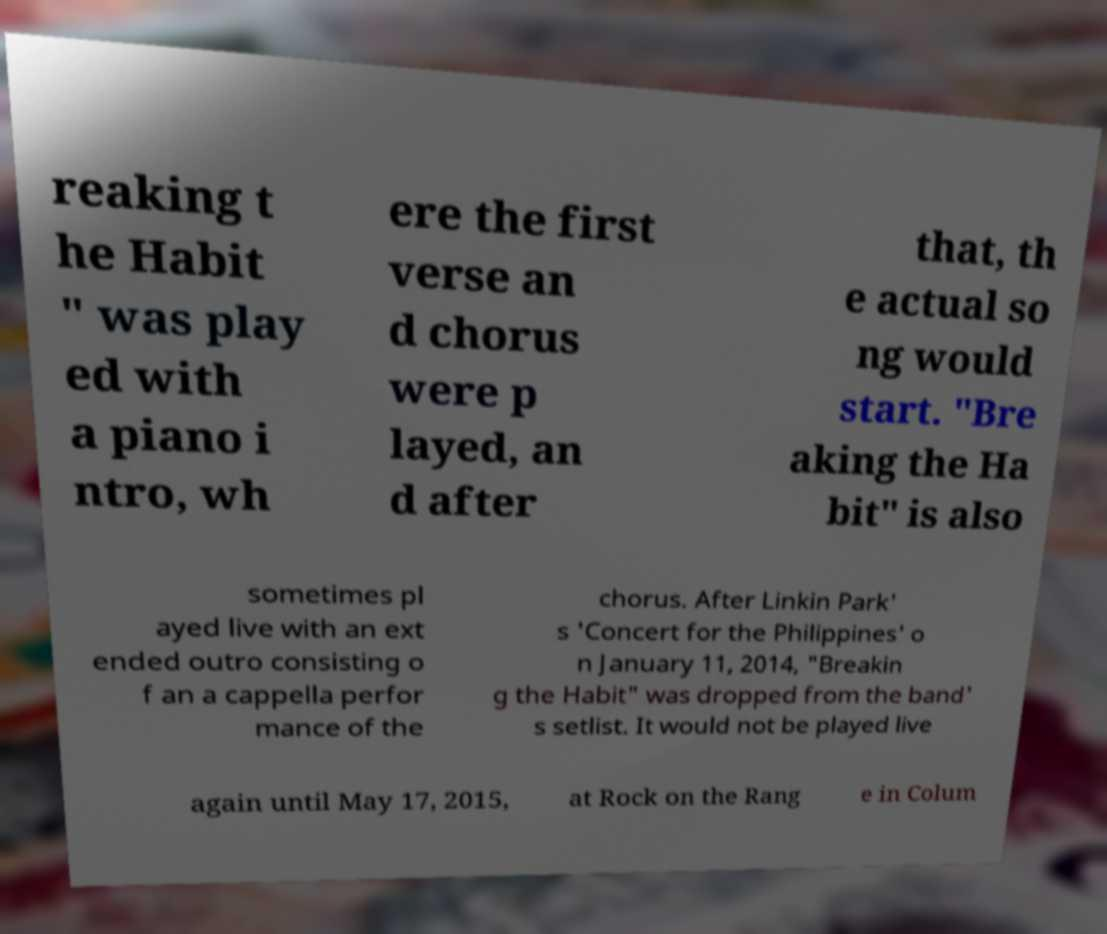Could you extract and type out the text from this image? reaking t he Habit " was play ed with a piano i ntro, wh ere the first verse an d chorus were p layed, an d after that, th e actual so ng would start. "Bre aking the Ha bit" is also sometimes pl ayed live with an ext ended outro consisting o f an a cappella perfor mance of the chorus. After Linkin Park' s 'Concert for the Philippines' o n January 11, 2014, "Breakin g the Habit" was dropped from the band' s setlist. It would not be played live again until May 17, 2015, at Rock on the Rang e in Colum 